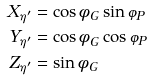<formula> <loc_0><loc_0><loc_500><loc_500>X _ { \eta ^ { \prime } } & = \cos \phi _ { G } \sin \varphi _ { P } \\ Y _ { \eta ^ { \prime } } & = \cos \phi _ { G } \cos \varphi _ { P } \\ Z _ { \eta ^ { \prime } } & = \sin \phi _ { G }</formula> 